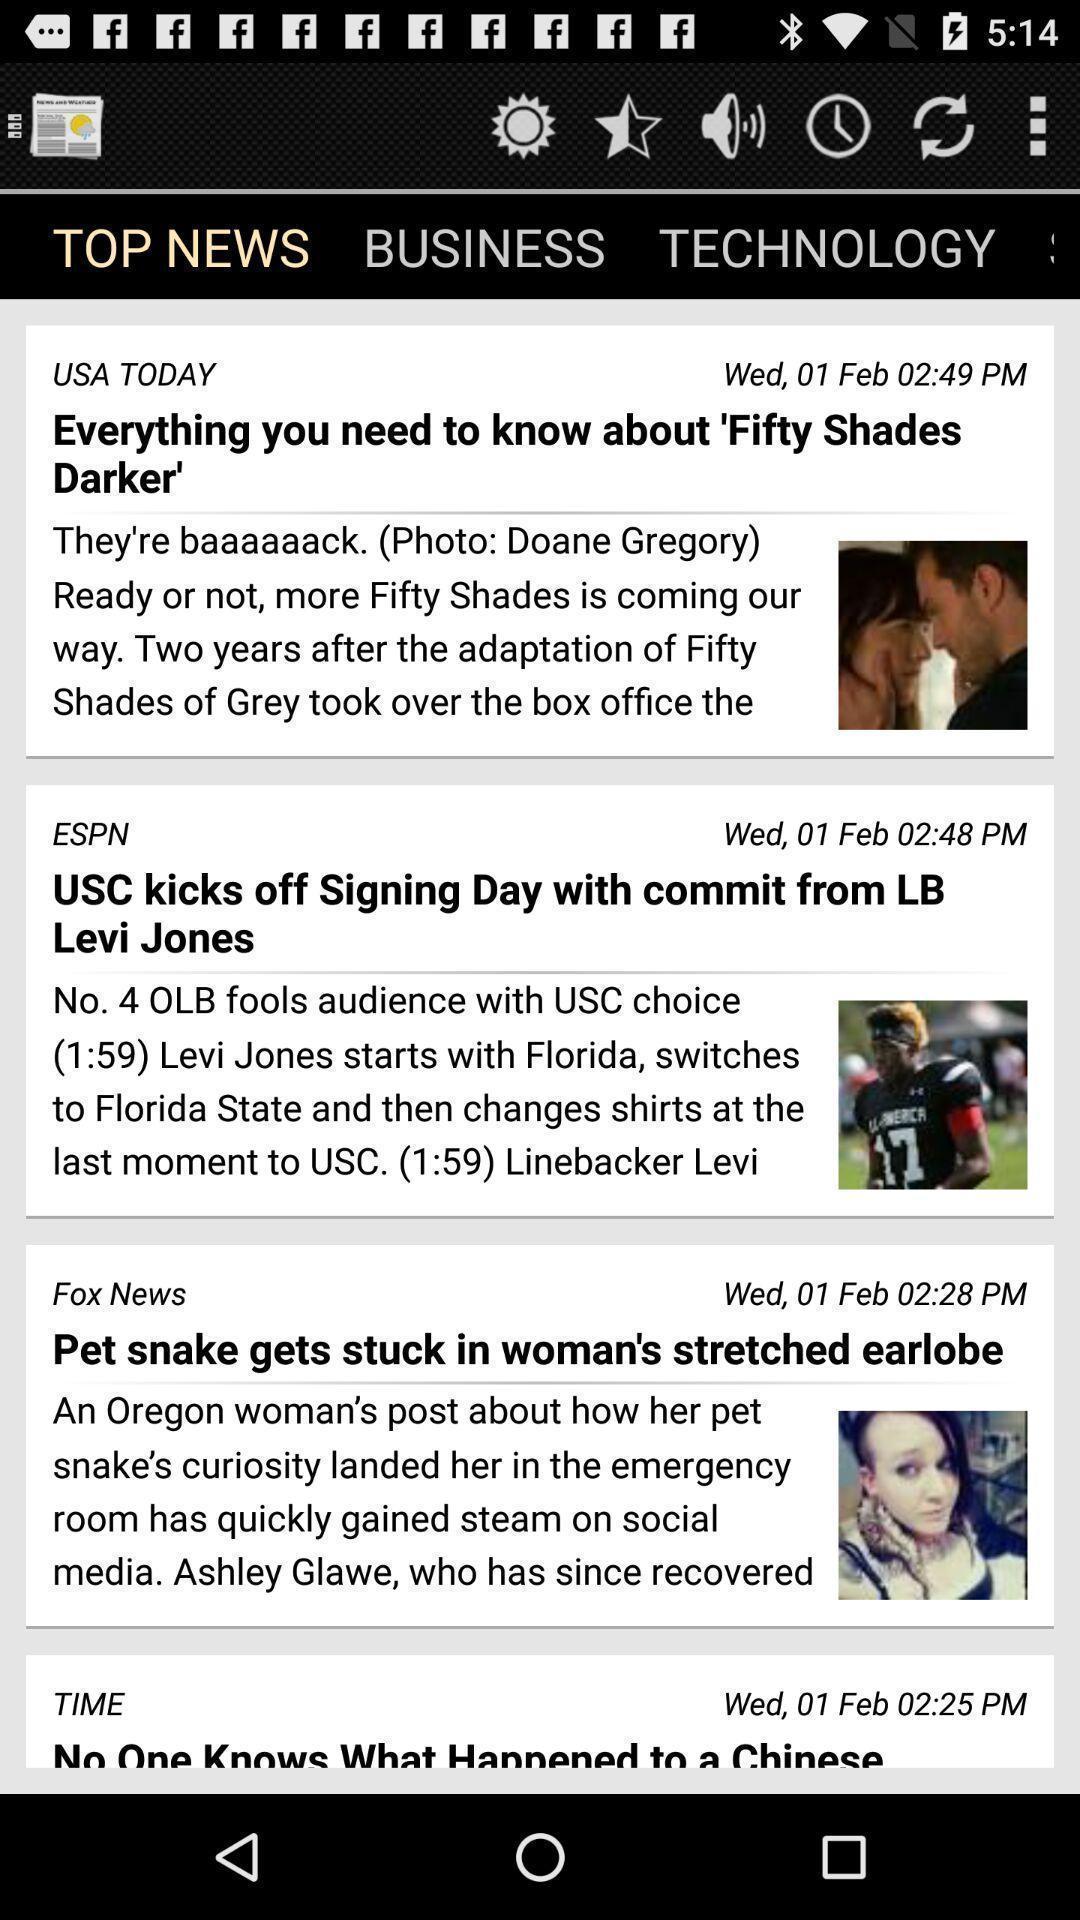Describe the key features of this screenshot. Screen showing a top news page on an app. 